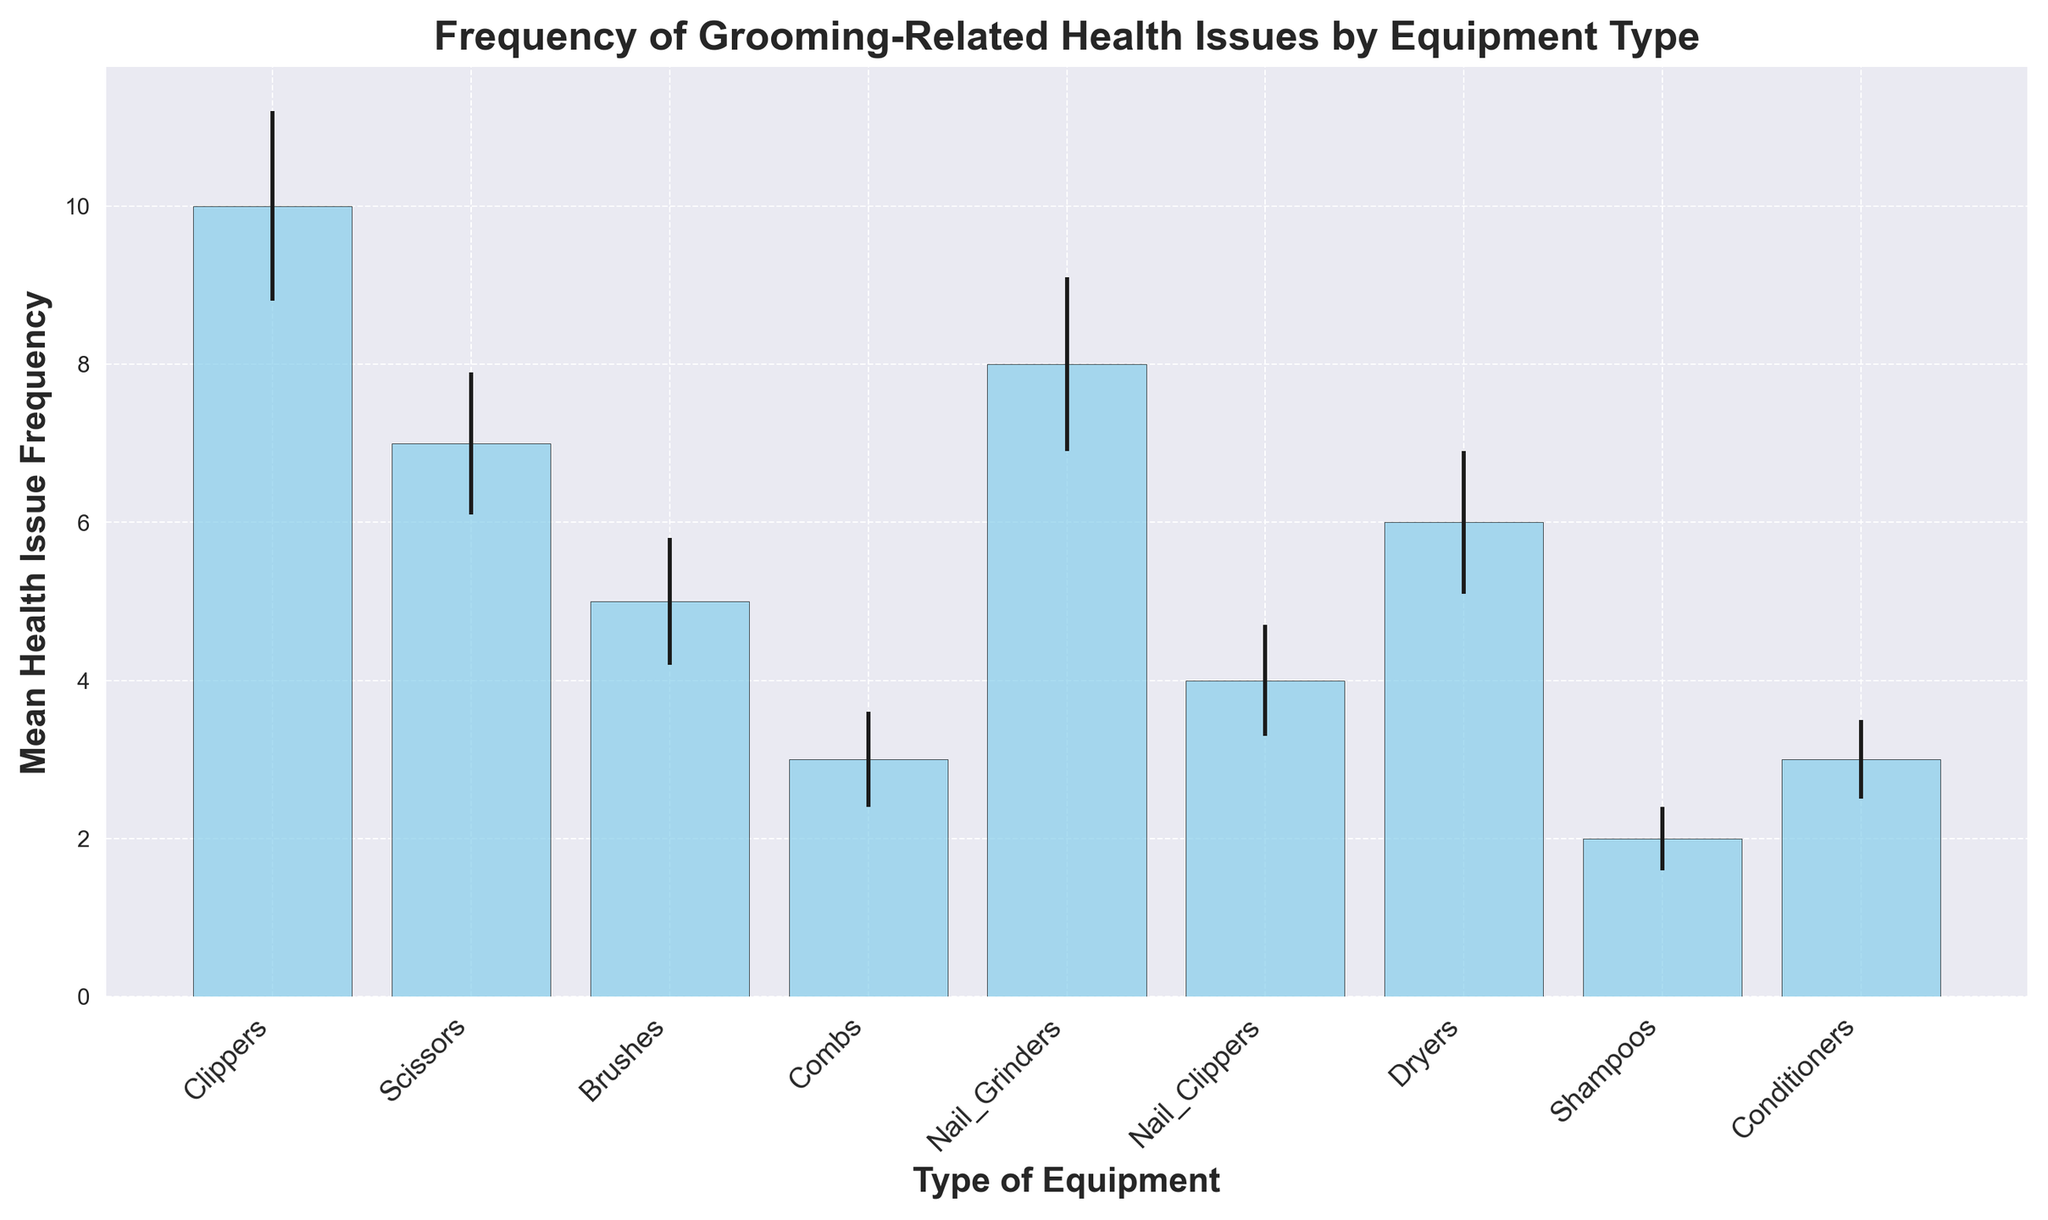Which type of grooming equipment is associated with the highest mean frequency of health issues? The bar representing "Clippers" has the tallest height, which indicates it has the highest mean health issue frequency.
Answer: Clippers Which two types of equipment have the closest mean frequency of health issues? By comparing the heights of the bars, "Brushes" and "Dryers" have very close mean frequencies, as their bars are nearly the same height.
Answer: Brushes and Dryers What is the sum of the mean health issue frequencies for "Scissors" and "Nail Grinders"? The mean frequency for "Scissors" is 7 and for "Nail Grinders" is 8. Adding them together gives 7 + 8.
Answer: 15 Which has a higher mean health issue frequency, "Combs" or "Nail Clippers"? The bar for "Nail Clippers" is slightly taller than the bar for "Combs", indicating a higher mean health issue frequency.
Answer: Nail Clippers What's the difference in mean health issue frequency between "Shampoos" and "Clippers"? The mean frequency for "Shampoos" is 2 and for "Clippers" is 10. Subtracting them gives 10 - 2.
Answer: 8 Which equipment type has the smallest error bar, indicating the lowest variability in health issue frequency? The error bar for "Shampoos" is the shortest, indicating the lowest variability in health issue frequency.
Answer: Shampoos How does the mean health issue frequency of "Conditioners" compare to "Combs"? Both "Conditioners" and "Combs" have very similar bar heights, indicating that their mean health issue frequencies are similar.
Answer: Similar Is the mean health issue frequency of "Nail Grinders" within the error range of "Clippers"? "Clippers" has a mean frequency of 10 with an error of 1.2, making the range 8.8 to 11.2. "Nail Grinders" has a mean frequency of 8, which is outside this range.
Answer: No By how much does the mean health issue frequency of "Dryers" differ from "Shampoos"? The mean frequency for "Dryers" is 6 and for "Shampoos" is 2. The difference is 6 - 2.
Answer: 4 